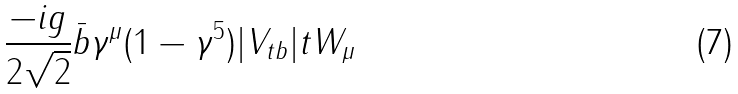<formula> <loc_0><loc_0><loc_500><loc_500>\frac { - i g } { 2 \sqrt { 2 } } \bar { b } \gamma ^ { \mu } ( 1 - \gamma ^ { 5 } ) | V _ { t b } | t W _ { \mu }</formula> 